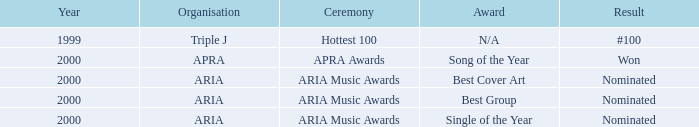Which accolade was up for nomination in 2000? Best Cover Art, Best Group, Single of the Year. 